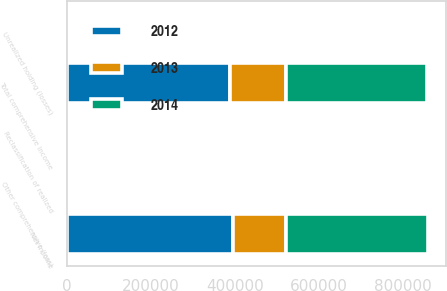Convert chart. <chart><loc_0><loc_0><loc_500><loc_500><stacked_bar_chart><ecel><fcel>Net income<fcel>Unrealized holding (losses)<fcel>Reclassification of realized<fcel>Other comprehensive (loss)<fcel>Total comprehensive income<nl><fcel>2012<fcel>395281<fcel>4377<fcel>1595<fcel>5884<fcel>389397<nl><fcel>2013<fcel>127389<fcel>2686<fcel>343<fcel>3834<fcel>131223<nl><fcel>2014<fcel>336705<fcel>41<fcel>215<fcel>256<fcel>336449<nl></chart> 